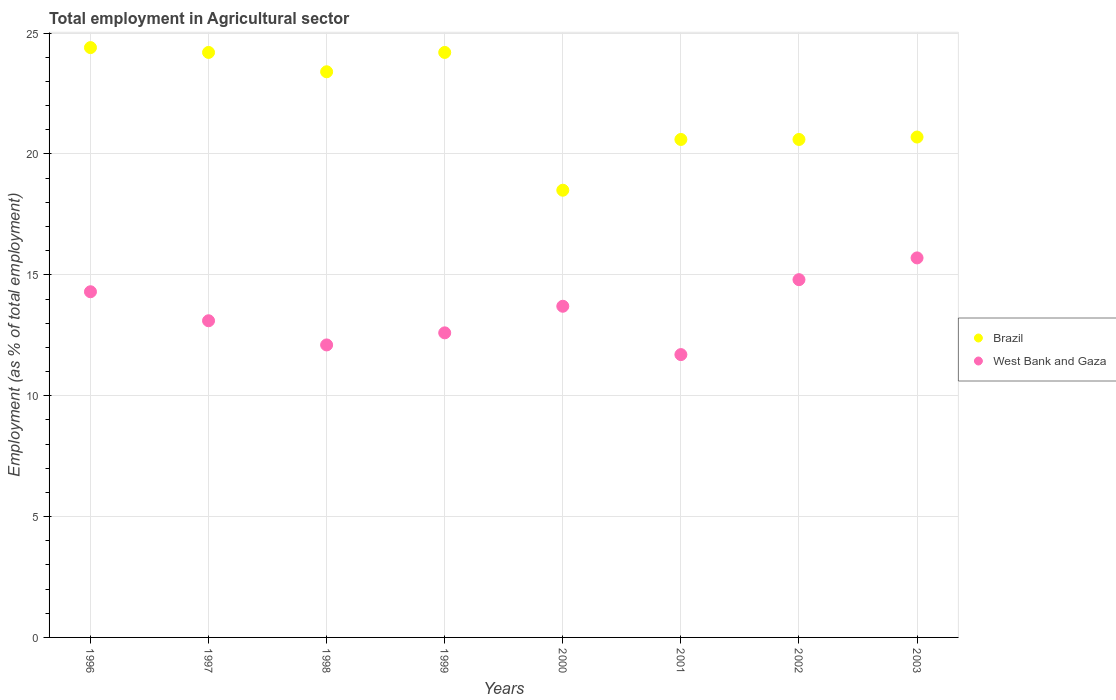What is the employment in agricultural sector in Brazil in 1996?
Your answer should be very brief. 24.4. Across all years, what is the maximum employment in agricultural sector in Brazil?
Your answer should be compact. 24.4. Across all years, what is the minimum employment in agricultural sector in West Bank and Gaza?
Make the answer very short. 11.7. In which year was the employment in agricultural sector in West Bank and Gaza minimum?
Offer a terse response. 2001. What is the total employment in agricultural sector in West Bank and Gaza in the graph?
Ensure brevity in your answer.  108. What is the difference between the employment in agricultural sector in West Bank and Gaza in 1998 and that in 2003?
Provide a short and direct response. -3.6. What is the difference between the employment in agricultural sector in West Bank and Gaza in 1998 and the employment in agricultural sector in Brazil in 1997?
Keep it short and to the point. -12.1. What is the average employment in agricultural sector in Brazil per year?
Your answer should be very brief. 22.08. In the year 1997, what is the difference between the employment in agricultural sector in West Bank and Gaza and employment in agricultural sector in Brazil?
Offer a very short reply. -11.1. What is the ratio of the employment in agricultural sector in West Bank and Gaza in 1996 to that in 1999?
Offer a terse response. 1.13. Is the employment in agricultural sector in Brazil in 1999 less than that in 2003?
Your answer should be very brief. No. What is the difference between the highest and the second highest employment in agricultural sector in West Bank and Gaza?
Your answer should be very brief. 0.9. What is the difference between the highest and the lowest employment in agricultural sector in West Bank and Gaza?
Make the answer very short. 4. How many dotlines are there?
Your response must be concise. 2. What is the difference between two consecutive major ticks on the Y-axis?
Ensure brevity in your answer.  5. Does the graph contain any zero values?
Provide a succinct answer. No. Does the graph contain grids?
Give a very brief answer. Yes. Where does the legend appear in the graph?
Provide a short and direct response. Center right. What is the title of the graph?
Give a very brief answer. Total employment in Agricultural sector. What is the label or title of the X-axis?
Provide a succinct answer. Years. What is the label or title of the Y-axis?
Your answer should be very brief. Employment (as % of total employment). What is the Employment (as % of total employment) in Brazil in 1996?
Offer a very short reply. 24.4. What is the Employment (as % of total employment) in West Bank and Gaza in 1996?
Your answer should be compact. 14.3. What is the Employment (as % of total employment) in Brazil in 1997?
Your answer should be compact. 24.2. What is the Employment (as % of total employment) of West Bank and Gaza in 1997?
Make the answer very short. 13.1. What is the Employment (as % of total employment) in Brazil in 1998?
Provide a succinct answer. 23.4. What is the Employment (as % of total employment) of West Bank and Gaza in 1998?
Make the answer very short. 12.1. What is the Employment (as % of total employment) of Brazil in 1999?
Offer a very short reply. 24.2. What is the Employment (as % of total employment) in West Bank and Gaza in 1999?
Ensure brevity in your answer.  12.6. What is the Employment (as % of total employment) of West Bank and Gaza in 2000?
Offer a very short reply. 13.7. What is the Employment (as % of total employment) in Brazil in 2001?
Give a very brief answer. 20.6. What is the Employment (as % of total employment) in West Bank and Gaza in 2001?
Give a very brief answer. 11.7. What is the Employment (as % of total employment) in Brazil in 2002?
Your answer should be very brief. 20.6. What is the Employment (as % of total employment) of West Bank and Gaza in 2002?
Keep it short and to the point. 14.8. What is the Employment (as % of total employment) in Brazil in 2003?
Keep it short and to the point. 20.7. What is the Employment (as % of total employment) in West Bank and Gaza in 2003?
Keep it short and to the point. 15.7. Across all years, what is the maximum Employment (as % of total employment) in Brazil?
Your answer should be very brief. 24.4. Across all years, what is the maximum Employment (as % of total employment) of West Bank and Gaza?
Your answer should be compact. 15.7. Across all years, what is the minimum Employment (as % of total employment) in Brazil?
Your response must be concise. 18.5. Across all years, what is the minimum Employment (as % of total employment) of West Bank and Gaza?
Ensure brevity in your answer.  11.7. What is the total Employment (as % of total employment) in Brazil in the graph?
Your answer should be very brief. 176.6. What is the total Employment (as % of total employment) in West Bank and Gaza in the graph?
Your answer should be compact. 108. What is the difference between the Employment (as % of total employment) in West Bank and Gaza in 1996 and that in 1997?
Your response must be concise. 1.2. What is the difference between the Employment (as % of total employment) of West Bank and Gaza in 1996 and that in 1998?
Make the answer very short. 2.2. What is the difference between the Employment (as % of total employment) of Brazil in 1996 and that in 2000?
Your answer should be compact. 5.9. What is the difference between the Employment (as % of total employment) in West Bank and Gaza in 1996 and that in 2000?
Keep it short and to the point. 0.6. What is the difference between the Employment (as % of total employment) in Brazil in 1996 and that in 2001?
Provide a short and direct response. 3.8. What is the difference between the Employment (as % of total employment) of West Bank and Gaza in 1996 and that in 2001?
Offer a terse response. 2.6. What is the difference between the Employment (as % of total employment) of West Bank and Gaza in 1996 and that in 2002?
Offer a terse response. -0.5. What is the difference between the Employment (as % of total employment) of Brazil in 1996 and that in 2003?
Your response must be concise. 3.7. What is the difference between the Employment (as % of total employment) of West Bank and Gaza in 1996 and that in 2003?
Your response must be concise. -1.4. What is the difference between the Employment (as % of total employment) in Brazil in 1997 and that in 1998?
Make the answer very short. 0.8. What is the difference between the Employment (as % of total employment) in West Bank and Gaza in 1997 and that in 1998?
Your response must be concise. 1. What is the difference between the Employment (as % of total employment) in Brazil in 1997 and that in 2000?
Your answer should be very brief. 5.7. What is the difference between the Employment (as % of total employment) in West Bank and Gaza in 1997 and that in 2000?
Offer a very short reply. -0.6. What is the difference between the Employment (as % of total employment) in Brazil in 1997 and that in 2001?
Ensure brevity in your answer.  3.6. What is the difference between the Employment (as % of total employment) of Brazil in 1997 and that in 2002?
Offer a very short reply. 3.6. What is the difference between the Employment (as % of total employment) in West Bank and Gaza in 1997 and that in 2003?
Provide a succinct answer. -2.6. What is the difference between the Employment (as % of total employment) of Brazil in 1998 and that in 1999?
Ensure brevity in your answer.  -0.8. What is the difference between the Employment (as % of total employment) in West Bank and Gaza in 1998 and that in 1999?
Provide a short and direct response. -0.5. What is the difference between the Employment (as % of total employment) in Brazil in 1998 and that in 2000?
Offer a terse response. 4.9. What is the difference between the Employment (as % of total employment) of West Bank and Gaza in 1998 and that in 2001?
Make the answer very short. 0.4. What is the difference between the Employment (as % of total employment) in West Bank and Gaza in 1998 and that in 2002?
Your answer should be compact. -2.7. What is the difference between the Employment (as % of total employment) in West Bank and Gaza in 1999 and that in 2000?
Your response must be concise. -1.1. What is the difference between the Employment (as % of total employment) of Brazil in 1999 and that in 2002?
Offer a very short reply. 3.6. What is the difference between the Employment (as % of total employment) in Brazil in 1999 and that in 2003?
Your response must be concise. 3.5. What is the difference between the Employment (as % of total employment) in West Bank and Gaza in 1999 and that in 2003?
Your answer should be compact. -3.1. What is the difference between the Employment (as % of total employment) of Brazil in 2000 and that in 2001?
Your response must be concise. -2.1. What is the difference between the Employment (as % of total employment) in Brazil in 2000 and that in 2002?
Your answer should be compact. -2.1. What is the difference between the Employment (as % of total employment) of West Bank and Gaza in 2000 and that in 2002?
Provide a succinct answer. -1.1. What is the difference between the Employment (as % of total employment) of West Bank and Gaza in 2001 and that in 2002?
Provide a short and direct response. -3.1. What is the difference between the Employment (as % of total employment) in Brazil in 2001 and that in 2003?
Give a very brief answer. -0.1. What is the difference between the Employment (as % of total employment) in Brazil in 1996 and the Employment (as % of total employment) in West Bank and Gaza in 1997?
Keep it short and to the point. 11.3. What is the difference between the Employment (as % of total employment) of Brazil in 1996 and the Employment (as % of total employment) of West Bank and Gaza in 1998?
Offer a very short reply. 12.3. What is the difference between the Employment (as % of total employment) of Brazil in 1996 and the Employment (as % of total employment) of West Bank and Gaza in 1999?
Your response must be concise. 11.8. What is the difference between the Employment (as % of total employment) in Brazil in 1996 and the Employment (as % of total employment) in West Bank and Gaza in 2003?
Offer a very short reply. 8.7. What is the difference between the Employment (as % of total employment) of Brazil in 1997 and the Employment (as % of total employment) of West Bank and Gaza in 1998?
Provide a succinct answer. 12.1. What is the difference between the Employment (as % of total employment) in Brazil in 1997 and the Employment (as % of total employment) in West Bank and Gaza in 2001?
Ensure brevity in your answer.  12.5. What is the difference between the Employment (as % of total employment) in Brazil in 1997 and the Employment (as % of total employment) in West Bank and Gaza in 2003?
Your answer should be very brief. 8.5. What is the difference between the Employment (as % of total employment) of Brazil in 1998 and the Employment (as % of total employment) of West Bank and Gaza in 2000?
Ensure brevity in your answer.  9.7. What is the difference between the Employment (as % of total employment) of Brazil in 1998 and the Employment (as % of total employment) of West Bank and Gaza in 2001?
Provide a succinct answer. 11.7. What is the difference between the Employment (as % of total employment) in Brazil in 1998 and the Employment (as % of total employment) in West Bank and Gaza in 2002?
Your response must be concise. 8.6. What is the difference between the Employment (as % of total employment) in Brazil in 1998 and the Employment (as % of total employment) in West Bank and Gaza in 2003?
Provide a succinct answer. 7.7. What is the difference between the Employment (as % of total employment) in Brazil in 1999 and the Employment (as % of total employment) in West Bank and Gaza in 2000?
Your answer should be compact. 10.5. What is the difference between the Employment (as % of total employment) in Brazil in 1999 and the Employment (as % of total employment) in West Bank and Gaza in 2001?
Your answer should be compact. 12.5. What is the difference between the Employment (as % of total employment) in Brazil in 1999 and the Employment (as % of total employment) in West Bank and Gaza in 2002?
Your response must be concise. 9.4. What is the difference between the Employment (as % of total employment) in Brazil in 1999 and the Employment (as % of total employment) in West Bank and Gaza in 2003?
Keep it short and to the point. 8.5. What is the difference between the Employment (as % of total employment) in Brazil in 2000 and the Employment (as % of total employment) in West Bank and Gaza in 2001?
Your answer should be very brief. 6.8. What is the difference between the Employment (as % of total employment) of Brazil in 2000 and the Employment (as % of total employment) of West Bank and Gaza in 2003?
Offer a very short reply. 2.8. What is the difference between the Employment (as % of total employment) of Brazil in 2001 and the Employment (as % of total employment) of West Bank and Gaza in 2002?
Keep it short and to the point. 5.8. What is the difference between the Employment (as % of total employment) in Brazil in 2002 and the Employment (as % of total employment) in West Bank and Gaza in 2003?
Your answer should be very brief. 4.9. What is the average Employment (as % of total employment) of Brazil per year?
Your answer should be compact. 22.07. What is the average Employment (as % of total employment) of West Bank and Gaza per year?
Provide a short and direct response. 13.5. In the year 1997, what is the difference between the Employment (as % of total employment) in Brazil and Employment (as % of total employment) in West Bank and Gaza?
Provide a succinct answer. 11.1. In the year 1998, what is the difference between the Employment (as % of total employment) in Brazil and Employment (as % of total employment) in West Bank and Gaza?
Keep it short and to the point. 11.3. In the year 2001, what is the difference between the Employment (as % of total employment) of Brazil and Employment (as % of total employment) of West Bank and Gaza?
Your answer should be compact. 8.9. In the year 2002, what is the difference between the Employment (as % of total employment) in Brazil and Employment (as % of total employment) in West Bank and Gaza?
Offer a terse response. 5.8. In the year 2003, what is the difference between the Employment (as % of total employment) of Brazil and Employment (as % of total employment) of West Bank and Gaza?
Provide a succinct answer. 5. What is the ratio of the Employment (as % of total employment) in Brazil in 1996 to that in 1997?
Offer a very short reply. 1.01. What is the ratio of the Employment (as % of total employment) in West Bank and Gaza in 1996 to that in 1997?
Offer a terse response. 1.09. What is the ratio of the Employment (as % of total employment) in Brazil in 1996 to that in 1998?
Offer a very short reply. 1.04. What is the ratio of the Employment (as % of total employment) in West Bank and Gaza in 1996 to that in 1998?
Ensure brevity in your answer.  1.18. What is the ratio of the Employment (as % of total employment) of Brazil in 1996 to that in 1999?
Offer a very short reply. 1.01. What is the ratio of the Employment (as % of total employment) in West Bank and Gaza in 1996 to that in 1999?
Provide a short and direct response. 1.13. What is the ratio of the Employment (as % of total employment) in Brazil in 1996 to that in 2000?
Keep it short and to the point. 1.32. What is the ratio of the Employment (as % of total employment) in West Bank and Gaza in 1996 to that in 2000?
Your response must be concise. 1.04. What is the ratio of the Employment (as % of total employment) in Brazil in 1996 to that in 2001?
Keep it short and to the point. 1.18. What is the ratio of the Employment (as % of total employment) of West Bank and Gaza in 1996 to that in 2001?
Your response must be concise. 1.22. What is the ratio of the Employment (as % of total employment) in Brazil in 1996 to that in 2002?
Your response must be concise. 1.18. What is the ratio of the Employment (as % of total employment) in West Bank and Gaza in 1996 to that in 2002?
Keep it short and to the point. 0.97. What is the ratio of the Employment (as % of total employment) of Brazil in 1996 to that in 2003?
Your answer should be compact. 1.18. What is the ratio of the Employment (as % of total employment) in West Bank and Gaza in 1996 to that in 2003?
Offer a terse response. 0.91. What is the ratio of the Employment (as % of total employment) in Brazil in 1997 to that in 1998?
Provide a succinct answer. 1.03. What is the ratio of the Employment (as % of total employment) of West Bank and Gaza in 1997 to that in 1998?
Your answer should be compact. 1.08. What is the ratio of the Employment (as % of total employment) of Brazil in 1997 to that in 1999?
Your response must be concise. 1. What is the ratio of the Employment (as % of total employment) of West Bank and Gaza in 1997 to that in 1999?
Offer a terse response. 1.04. What is the ratio of the Employment (as % of total employment) of Brazil in 1997 to that in 2000?
Offer a terse response. 1.31. What is the ratio of the Employment (as % of total employment) in West Bank and Gaza in 1997 to that in 2000?
Your answer should be very brief. 0.96. What is the ratio of the Employment (as % of total employment) of Brazil in 1997 to that in 2001?
Offer a terse response. 1.17. What is the ratio of the Employment (as % of total employment) of West Bank and Gaza in 1997 to that in 2001?
Keep it short and to the point. 1.12. What is the ratio of the Employment (as % of total employment) of Brazil in 1997 to that in 2002?
Give a very brief answer. 1.17. What is the ratio of the Employment (as % of total employment) in West Bank and Gaza in 1997 to that in 2002?
Your answer should be very brief. 0.89. What is the ratio of the Employment (as % of total employment) in Brazil in 1997 to that in 2003?
Your response must be concise. 1.17. What is the ratio of the Employment (as % of total employment) of West Bank and Gaza in 1997 to that in 2003?
Ensure brevity in your answer.  0.83. What is the ratio of the Employment (as % of total employment) of Brazil in 1998 to that in 1999?
Keep it short and to the point. 0.97. What is the ratio of the Employment (as % of total employment) in West Bank and Gaza in 1998 to that in 1999?
Keep it short and to the point. 0.96. What is the ratio of the Employment (as % of total employment) in Brazil in 1998 to that in 2000?
Provide a short and direct response. 1.26. What is the ratio of the Employment (as % of total employment) in West Bank and Gaza in 1998 to that in 2000?
Provide a short and direct response. 0.88. What is the ratio of the Employment (as % of total employment) in Brazil in 1998 to that in 2001?
Your answer should be compact. 1.14. What is the ratio of the Employment (as % of total employment) of West Bank and Gaza in 1998 to that in 2001?
Give a very brief answer. 1.03. What is the ratio of the Employment (as % of total employment) in Brazil in 1998 to that in 2002?
Make the answer very short. 1.14. What is the ratio of the Employment (as % of total employment) of West Bank and Gaza in 1998 to that in 2002?
Offer a terse response. 0.82. What is the ratio of the Employment (as % of total employment) of Brazil in 1998 to that in 2003?
Keep it short and to the point. 1.13. What is the ratio of the Employment (as % of total employment) in West Bank and Gaza in 1998 to that in 2003?
Give a very brief answer. 0.77. What is the ratio of the Employment (as % of total employment) of Brazil in 1999 to that in 2000?
Offer a terse response. 1.31. What is the ratio of the Employment (as % of total employment) in West Bank and Gaza in 1999 to that in 2000?
Ensure brevity in your answer.  0.92. What is the ratio of the Employment (as % of total employment) in Brazil in 1999 to that in 2001?
Your answer should be very brief. 1.17. What is the ratio of the Employment (as % of total employment) in West Bank and Gaza in 1999 to that in 2001?
Offer a terse response. 1.08. What is the ratio of the Employment (as % of total employment) of Brazil in 1999 to that in 2002?
Keep it short and to the point. 1.17. What is the ratio of the Employment (as % of total employment) of West Bank and Gaza in 1999 to that in 2002?
Your response must be concise. 0.85. What is the ratio of the Employment (as % of total employment) of Brazil in 1999 to that in 2003?
Keep it short and to the point. 1.17. What is the ratio of the Employment (as % of total employment) of West Bank and Gaza in 1999 to that in 2003?
Keep it short and to the point. 0.8. What is the ratio of the Employment (as % of total employment) of Brazil in 2000 to that in 2001?
Your answer should be very brief. 0.9. What is the ratio of the Employment (as % of total employment) in West Bank and Gaza in 2000 to that in 2001?
Provide a short and direct response. 1.17. What is the ratio of the Employment (as % of total employment) in Brazil in 2000 to that in 2002?
Your response must be concise. 0.9. What is the ratio of the Employment (as % of total employment) in West Bank and Gaza in 2000 to that in 2002?
Provide a succinct answer. 0.93. What is the ratio of the Employment (as % of total employment) of Brazil in 2000 to that in 2003?
Give a very brief answer. 0.89. What is the ratio of the Employment (as % of total employment) in West Bank and Gaza in 2000 to that in 2003?
Keep it short and to the point. 0.87. What is the ratio of the Employment (as % of total employment) of West Bank and Gaza in 2001 to that in 2002?
Your answer should be compact. 0.79. What is the ratio of the Employment (as % of total employment) in West Bank and Gaza in 2001 to that in 2003?
Offer a terse response. 0.75. What is the ratio of the Employment (as % of total employment) of West Bank and Gaza in 2002 to that in 2003?
Offer a very short reply. 0.94. What is the difference between the highest and the second highest Employment (as % of total employment) in Brazil?
Provide a short and direct response. 0.2. What is the difference between the highest and the lowest Employment (as % of total employment) of West Bank and Gaza?
Give a very brief answer. 4. 